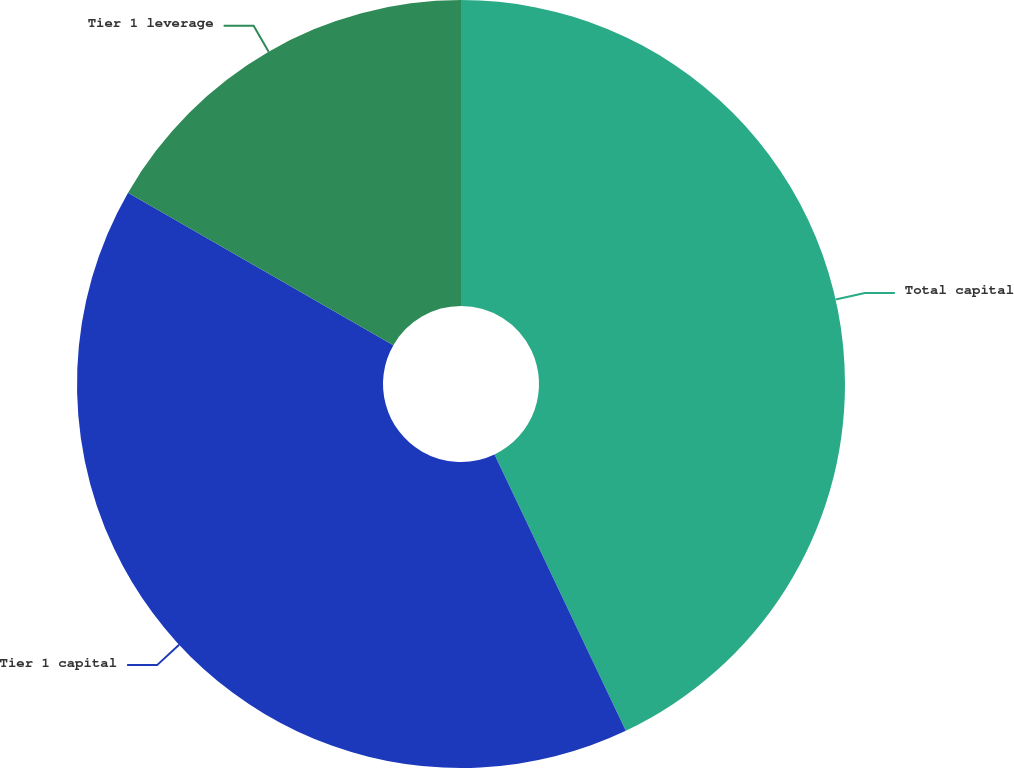Convert chart. <chart><loc_0><loc_0><loc_500><loc_500><pie_chart><fcel>Total capital<fcel>Tier 1 capital<fcel>Tier 1 leverage<nl><fcel>42.94%<fcel>40.36%<fcel>16.7%<nl></chart> 